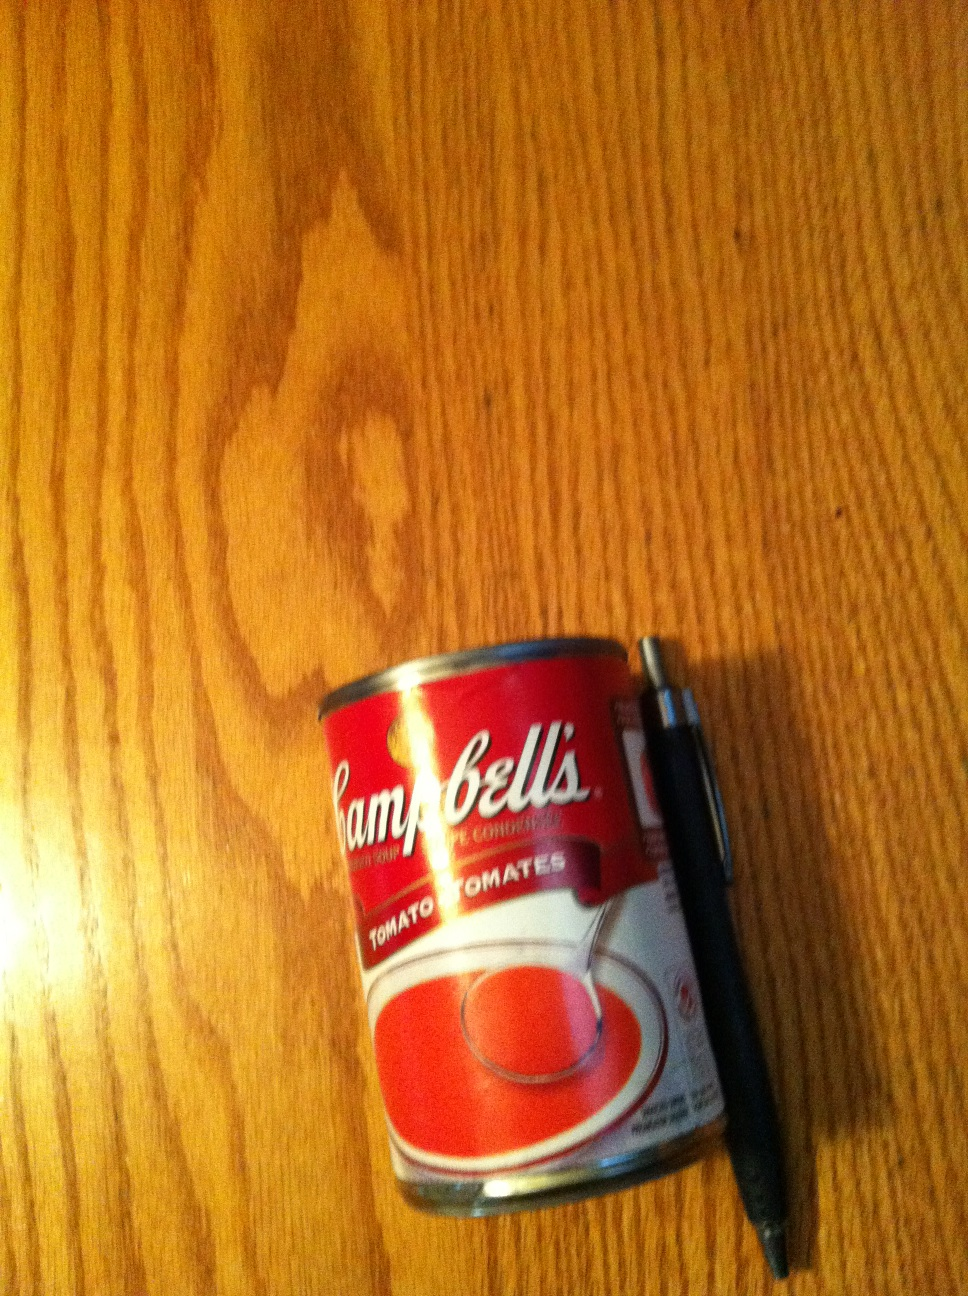Why is this can photographed next to a pen? Is there any significance? The pen next to the can provides a sense of scale, showing how big the can is. It also suggests that whoever took the photo might have been inventorying pantry items or planning a shopping list. Can you tell if the can is full or empty just by looking at this image? Without being able to pick up the can or observe other signs like dents or weight, it's difficult to tell for certain if the can is full or empty in this image. The lack of any visible damage or openings suggests it's likely still full and unopened. 